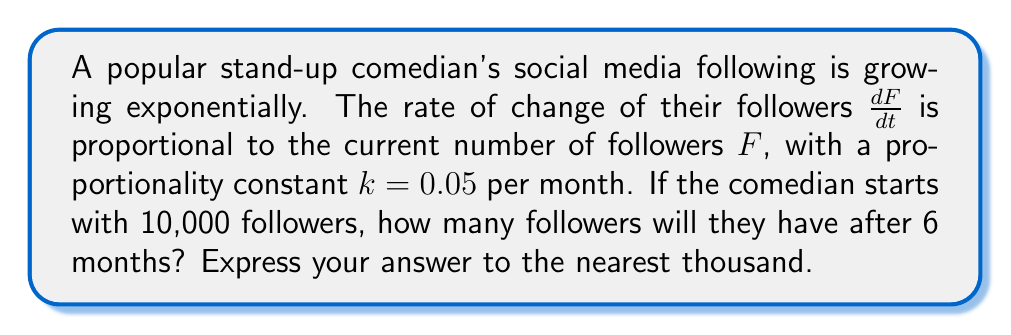Give your solution to this math problem. To solve this problem, we need to use the principles of exponential growth, which is modeled by a first-order ordinary differential equation.

1) The given information can be expressed as:
   $$\frac{dF}{dt} = kF$$
   where $k = 0.05$ per month, and the initial condition is $F(0) = 10,000$.

2) The general solution to this differential equation is:
   $$F(t) = Ce^{kt}$$
   where $C$ is a constant we need to determine.

3) Using the initial condition, we can find $C$:
   $$F(0) = Ce^{k(0)} = C = 10,000$$

4) Now we have the specific solution:
   $$F(t) = 10,000e^{0.05t}$$

5) To find the number of followers after 6 months, we substitute $t = 6$:
   $$F(6) = 10,000e^{0.05(6)} = 10,000e^{0.3}$$

6) Calculate this value:
   $$F(6) = 10,000 * 1.3498588 = 13,498.588$$

7) Rounding to the nearest thousand:
   $$F(6) \approx 13,000$$
Answer: 13,000 followers 